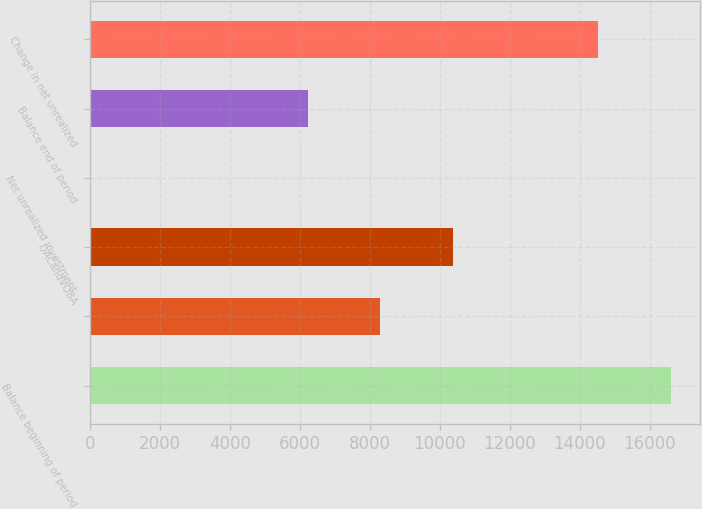Convert chart. <chart><loc_0><loc_0><loc_500><loc_500><bar_chart><fcel>Balance beginning of period<fcel>Unnamed: 1<fcel>DACandVOBA<fcel>Net unrealized investment<fcel>Balance end of period<fcel>Change in net unrealized<nl><fcel>16598.2<fcel>8304.6<fcel>10378<fcel>11<fcel>6231.2<fcel>14524.8<nl></chart> 